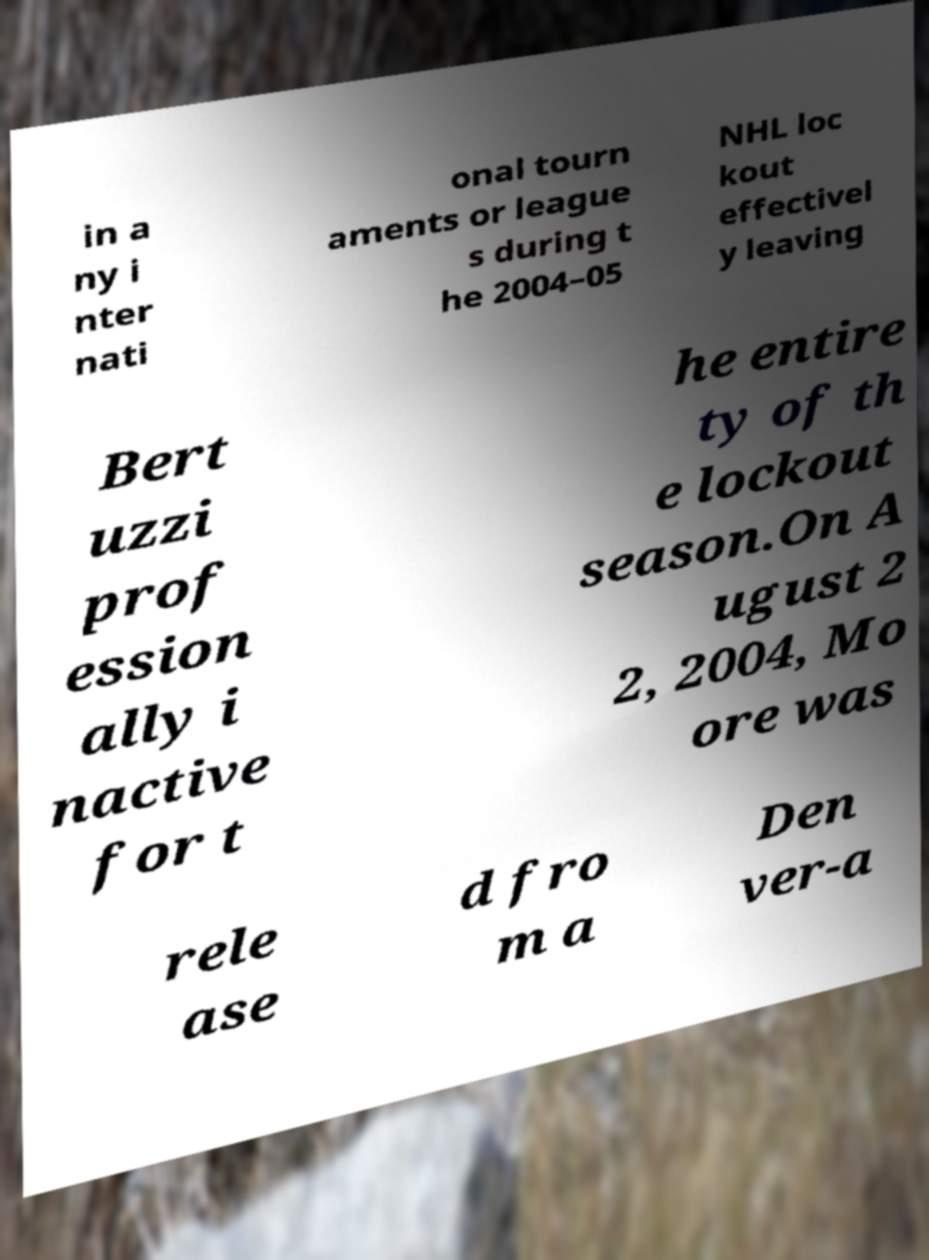There's text embedded in this image that I need extracted. Can you transcribe it verbatim? in a ny i nter nati onal tourn aments or league s during t he 2004–05 NHL loc kout effectivel y leaving Bert uzzi prof ession ally i nactive for t he entire ty of th e lockout season.On A ugust 2 2, 2004, Mo ore was rele ase d fro m a Den ver-a 